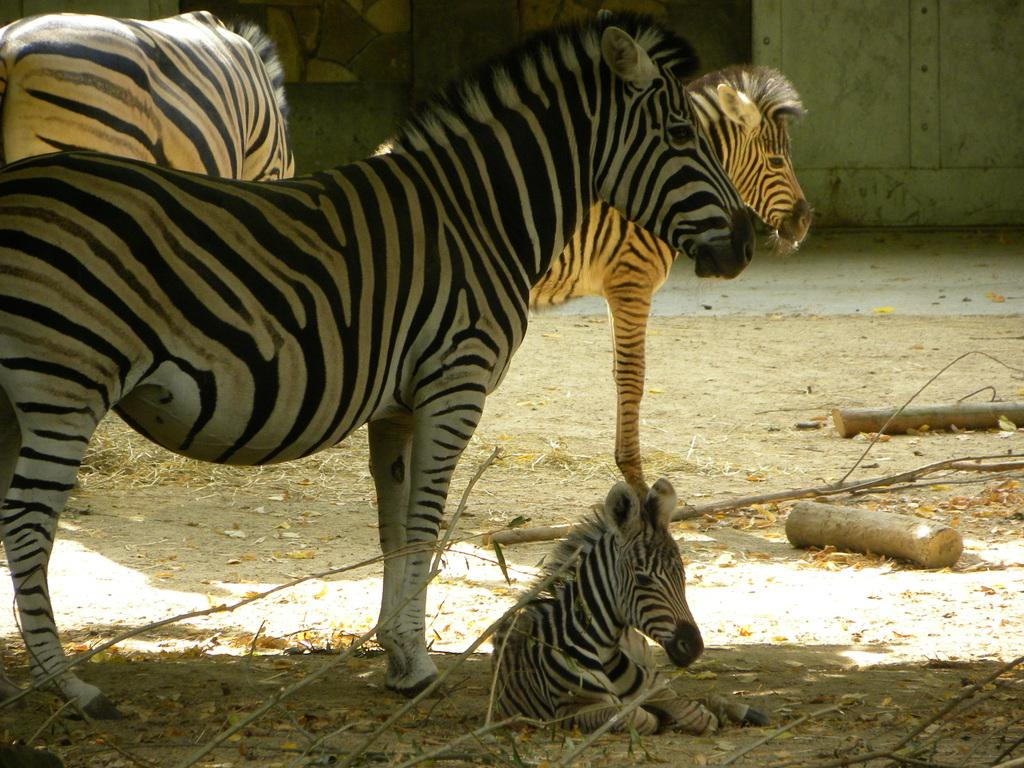What animals can be seen in the image? There are zebras in the image. What is on the ground in the image? There are branches of a tree on the ground in the image. What can be seen in the background of the image? There is a wall visible in the background of the image. What type of engine can be seen in the image? There is no engine present in the image. How many lines are visible in the image? The image does not contain any lines; it features zebras, branches, and a wall. 